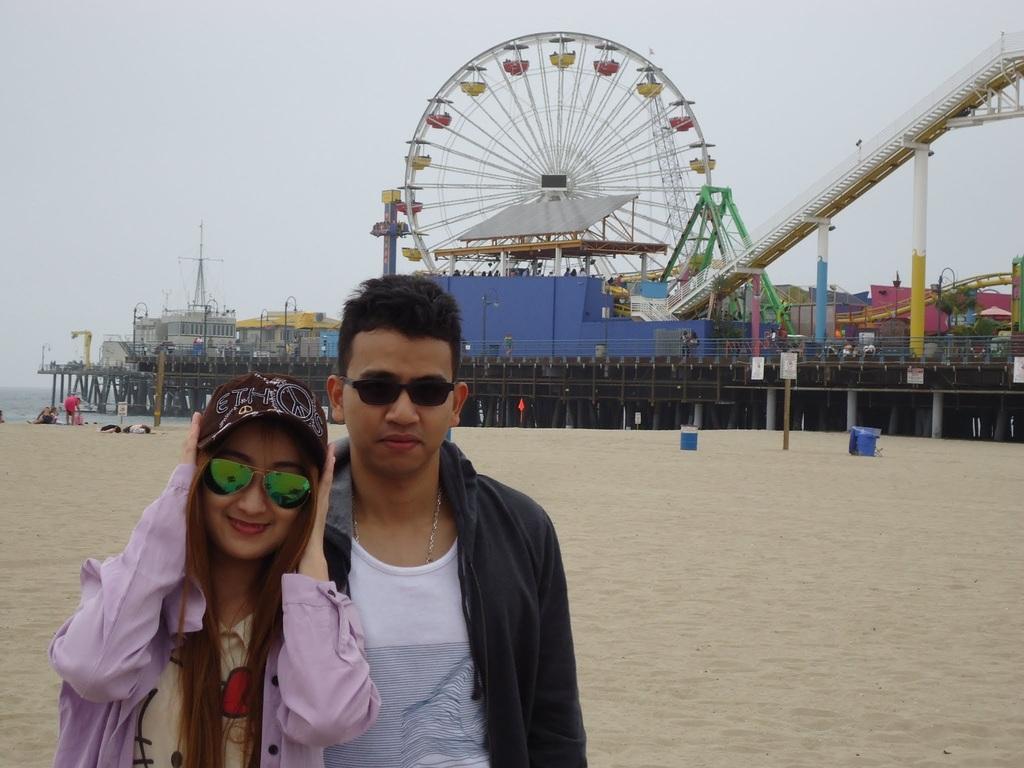Could you give a brief overview of what you see in this image? In the image there is a man and woman standing on the left side, both of them are wearing jackets and spects and behind them there is giant wheel and many play things, it seems to be a carnival, the land is covered with sand above its sky. 